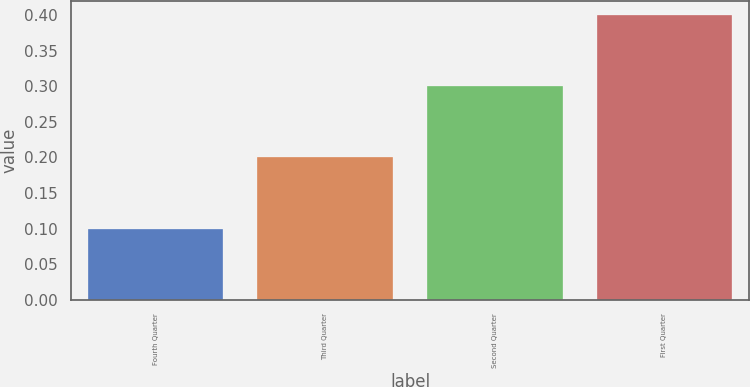Convert chart. <chart><loc_0><loc_0><loc_500><loc_500><bar_chart><fcel>Fourth Quarter<fcel>Third Quarter<fcel>Second Quarter<fcel>First Quarter<nl><fcel>0.1<fcel>0.2<fcel>0.3<fcel>0.4<nl></chart> 